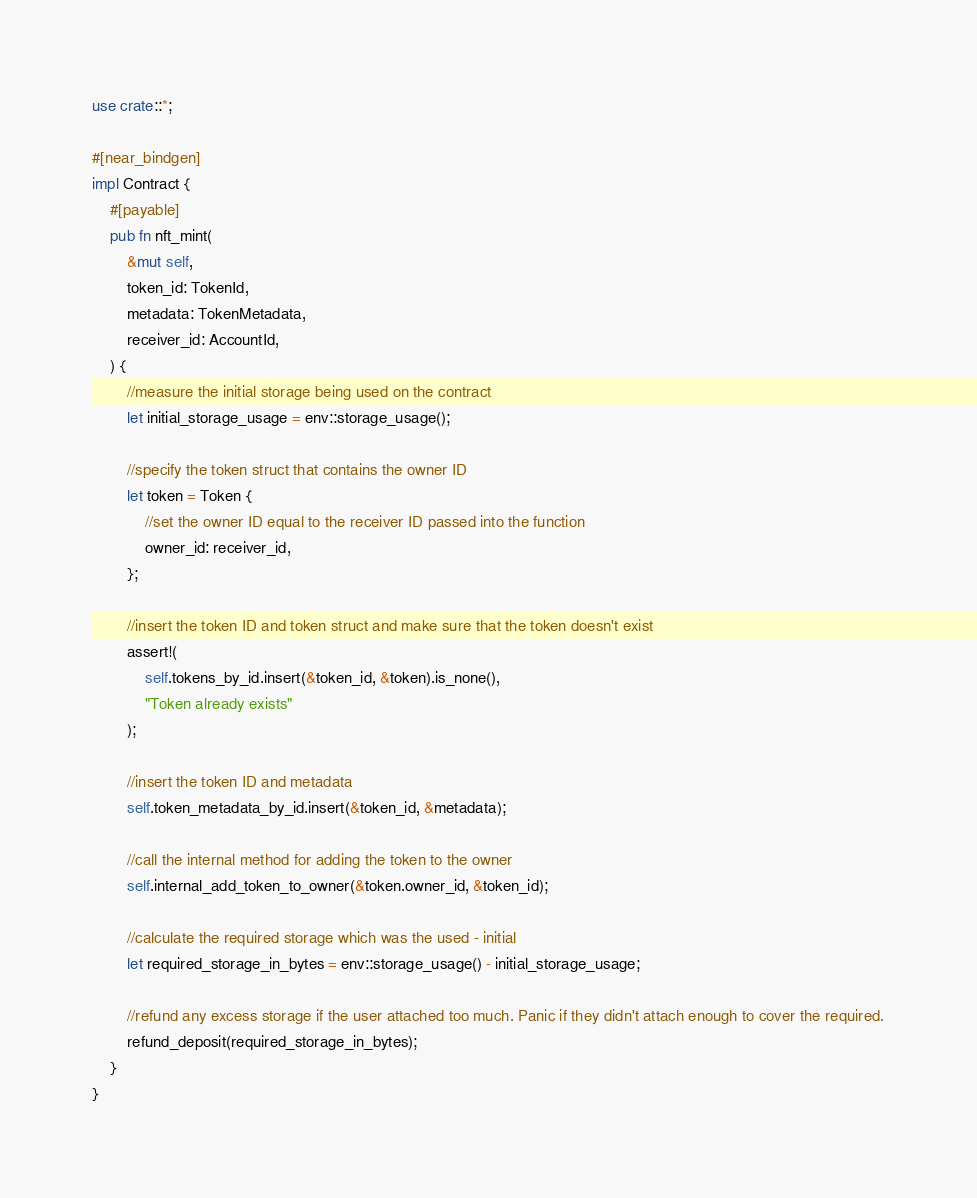<code> <loc_0><loc_0><loc_500><loc_500><_Rust_>use crate::*;

#[near_bindgen]
impl Contract {
    #[payable]
    pub fn nft_mint(
        &mut self,
        token_id: TokenId,
        metadata: TokenMetadata,
        receiver_id: AccountId,
    ) {
        //measure the initial storage being used on the contract
        let initial_storage_usage = env::storage_usage();

        //specify the token struct that contains the owner ID 
        let token = Token {
            //set the owner ID equal to the receiver ID passed into the function
            owner_id: receiver_id,
        };

        //insert the token ID and token struct and make sure that the token doesn't exist
        assert!(
            self.tokens_by_id.insert(&token_id, &token).is_none(),
            "Token already exists"
        );

        //insert the token ID and metadata
        self.token_metadata_by_id.insert(&token_id, &metadata);

        //call the internal method for adding the token to the owner
        self.internal_add_token_to_owner(&token.owner_id, &token_id);

        //calculate the required storage which was the used - initial
        let required_storage_in_bytes = env::storage_usage() - initial_storage_usage;

        //refund any excess storage if the user attached too much. Panic if they didn't attach enough to cover the required.
        refund_deposit(required_storage_in_bytes);
    }
}</code> 